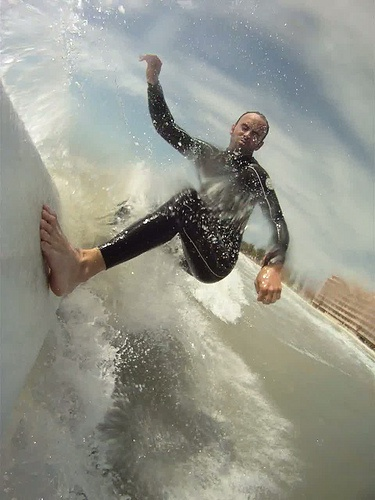Describe the objects in this image and their specific colors. I can see people in lightgray, black, gray, maroon, and darkgray tones and surfboard in lightgray and gray tones in this image. 